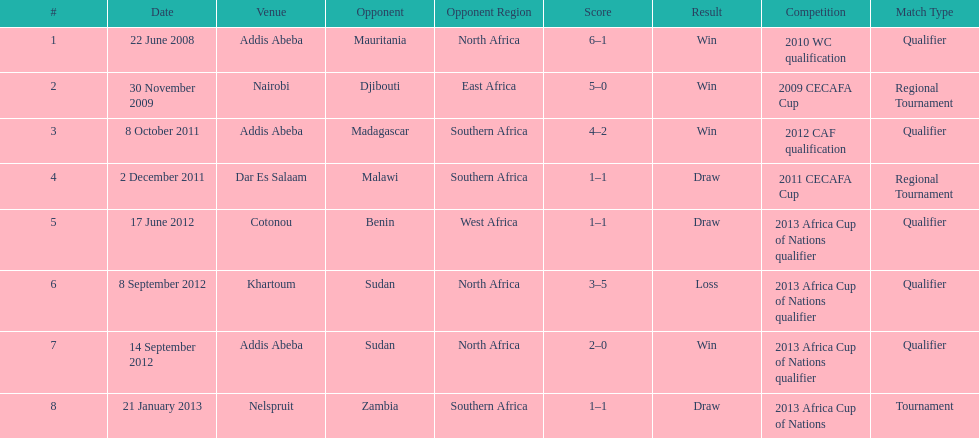For each winning game, what was their score? 6-1, 5-0, 4-2, 2-0. 